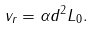Convert formula to latex. <formula><loc_0><loc_0><loc_500><loc_500>v _ { r } = \alpha d ^ { 2 } L _ { 0 } .</formula> 